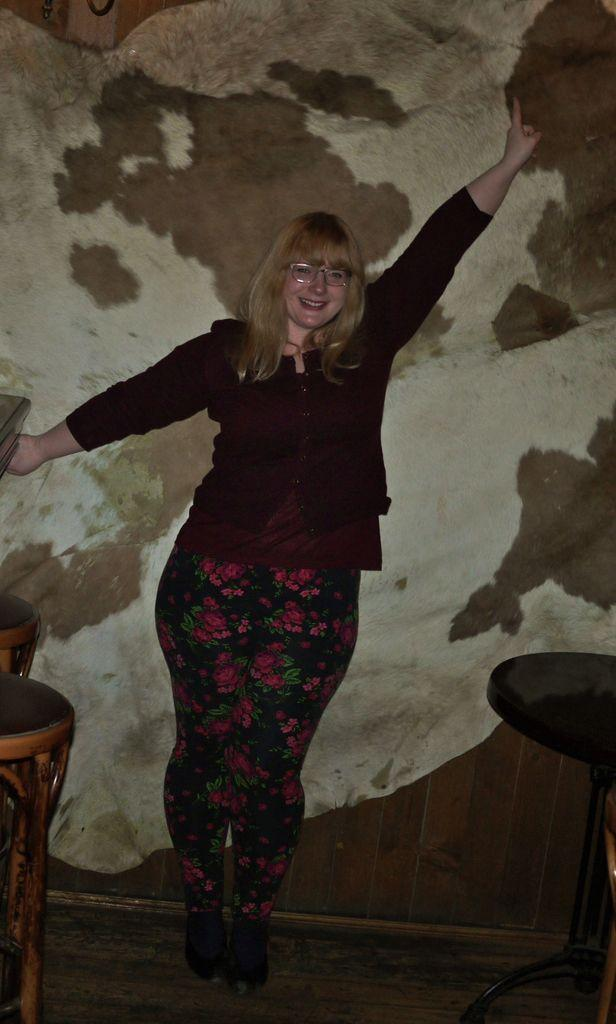Who is present in the image? There is a woman in the image. What is the woman doing in the image? The woman is standing on the floor and smiling. What type of furniture can be seen in the image? There are tables and chairs in the image. What is visible in the background of the image? There is a wall in the background of the image. What type of meat is the woman cooking in the image? There is no meat or cooking activity present in the image. What drug is the woman using in the image? There is no drug or drug use depicted in the image. 